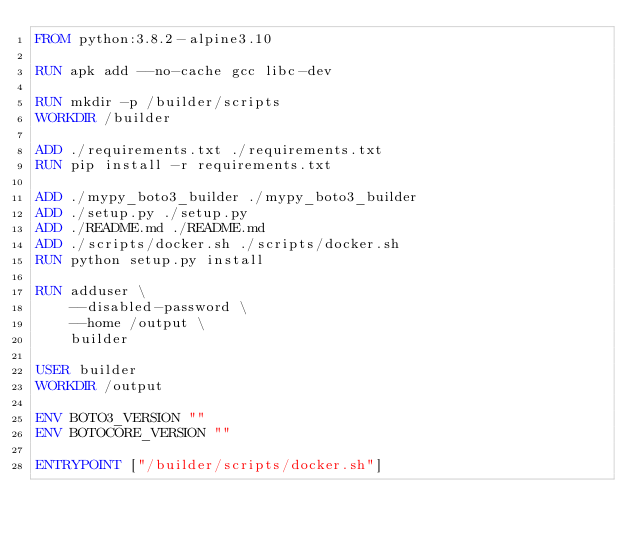<code> <loc_0><loc_0><loc_500><loc_500><_Dockerfile_>FROM python:3.8.2-alpine3.10

RUN apk add --no-cache gcc libc-dev

RUN mkdir -p /builder/scripts
WORKDIR /builder

ADD ./requirements.txt ./requirements.txt
RUN pip install -r requirements.txt

ADD ./mypy_boto3_builder ./mypy_boto3_builder
ADD ./setup.py ./setup.py
ADD ./README.md ./README.md
ADD ./scripts/docker.sh ./scripts/docker.sh
RUN python setup.py install

RUN adduser \
    --disabled-password \
    --home /output \
    builder

USER builder
WORKDIR /output

ENV BOTO3_VERSION ""
ENV BOTOCORE_VERSION ""

ENTRYPOINT ["/builder/scripts/docker.sh"]
</code> 